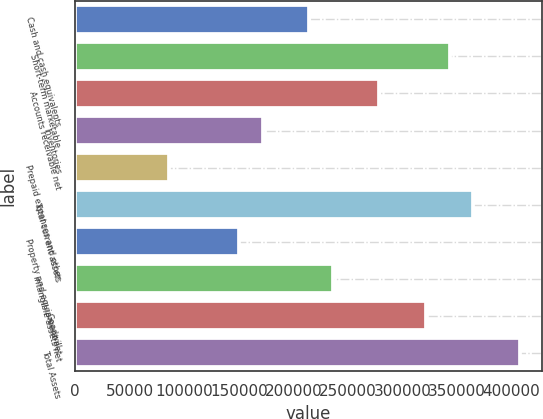Convert chart. <chart><loc_0><loc_0><loc_500><loc_500><bar_chart><fcel>Cash and cash equivalents<fcel>Short-term marketable<fcel>Accounts receivable net<fcel>Inventories<fcel>Prepaid expenses and other<fcel>Total current assets<fcel>Property and equipment net<fcel>Intangible assets net<fcel>Goodwill<fcel>Total Assets<nl><fcel>214666<fcel>343426<fcel>279046<fcel>171746<fcel>85906<fcel>364886<fcel>150286<fcel>236126<fcel>321966<fcel>407806<nl></chart> 